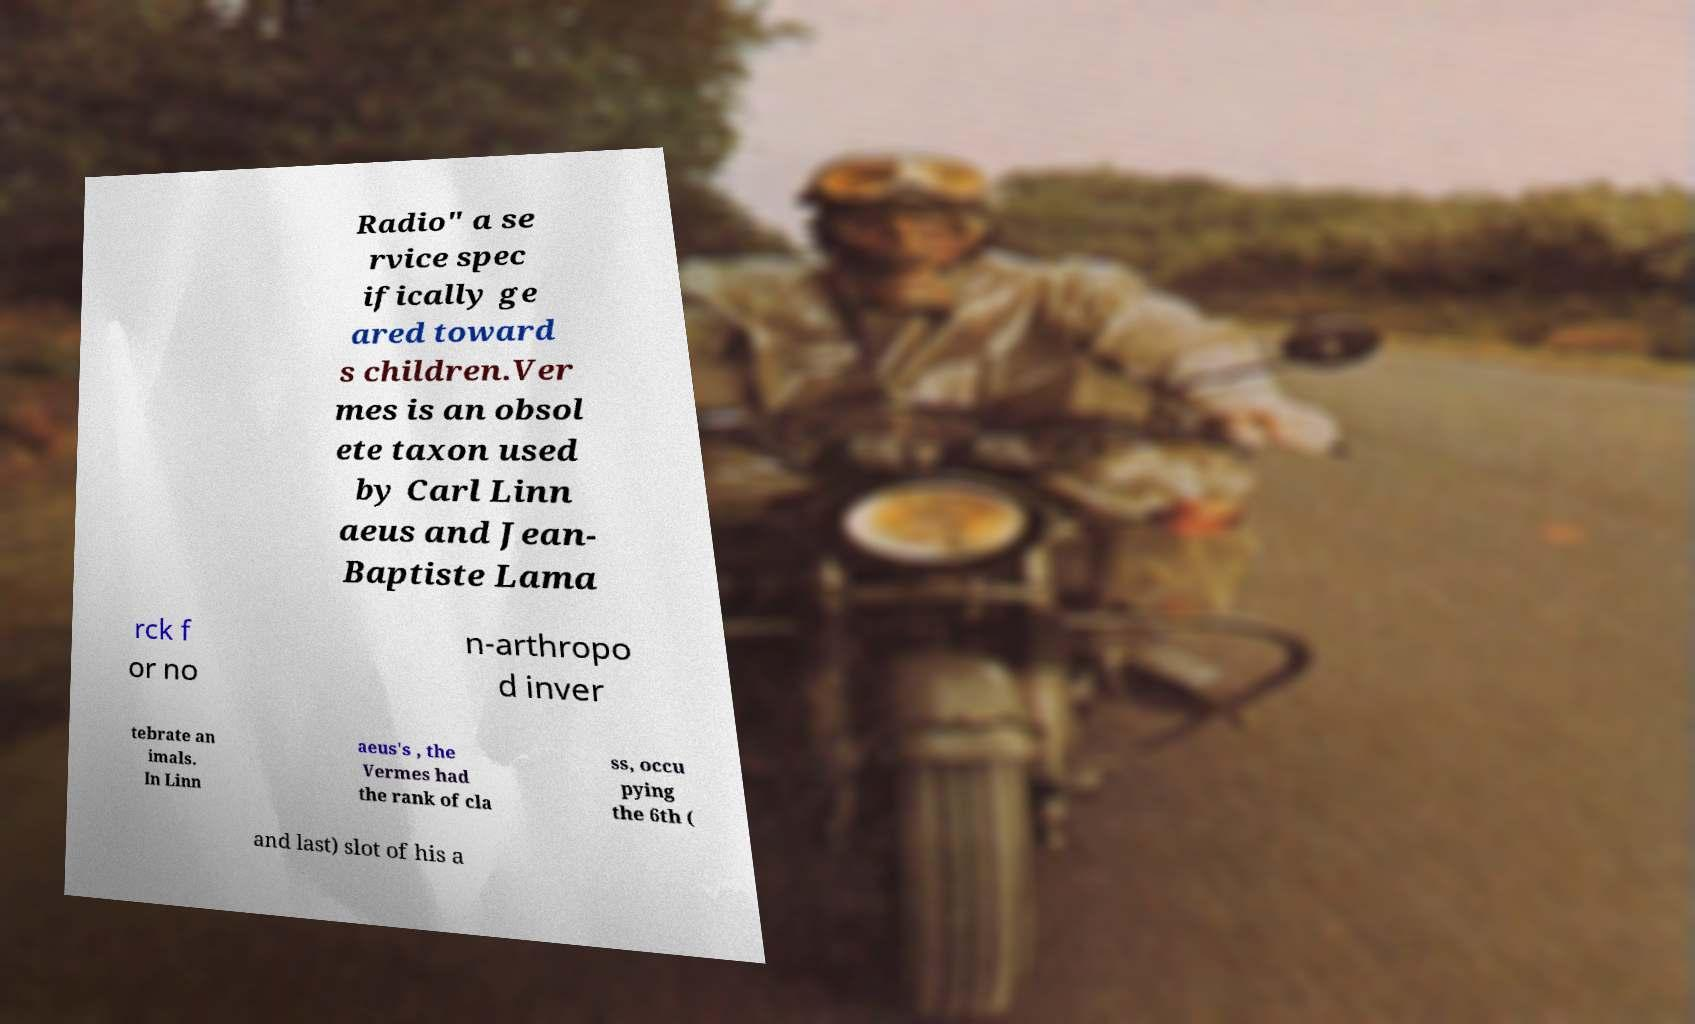Please identify and transcribe the text found in this image. Radio" a se rvice spec ifically ge ared toward s children.Ver mes is an obsol ete taxon used by Carl Linn aeus and Jean- Baptiste Lama rck f or no n-arthropo d inver tebrate an imals. In Linn aeus's , the Vermes had the rank of cla ss, occu pying the 6th ( and last) slot of his a 